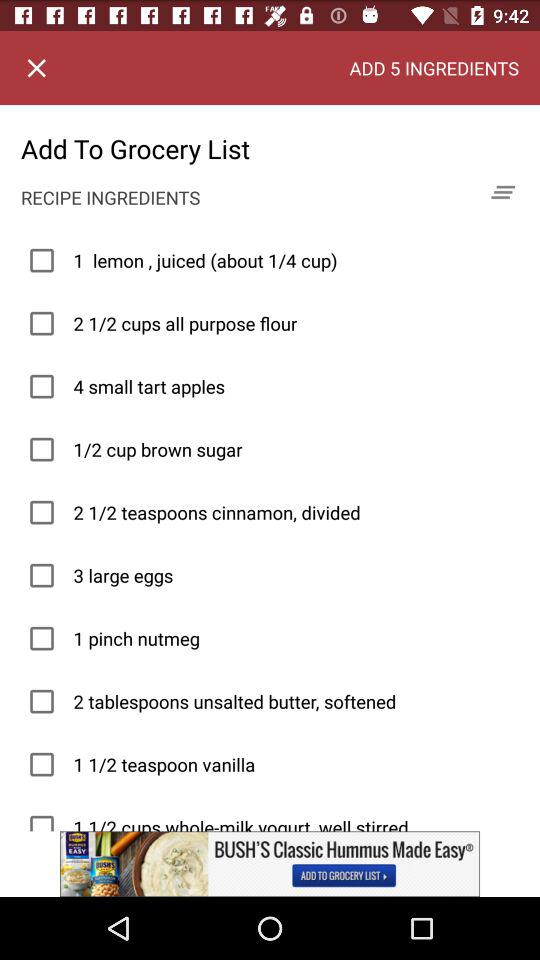How many ingredients can be added in total? There are 5 ingredients in total that can be added. 